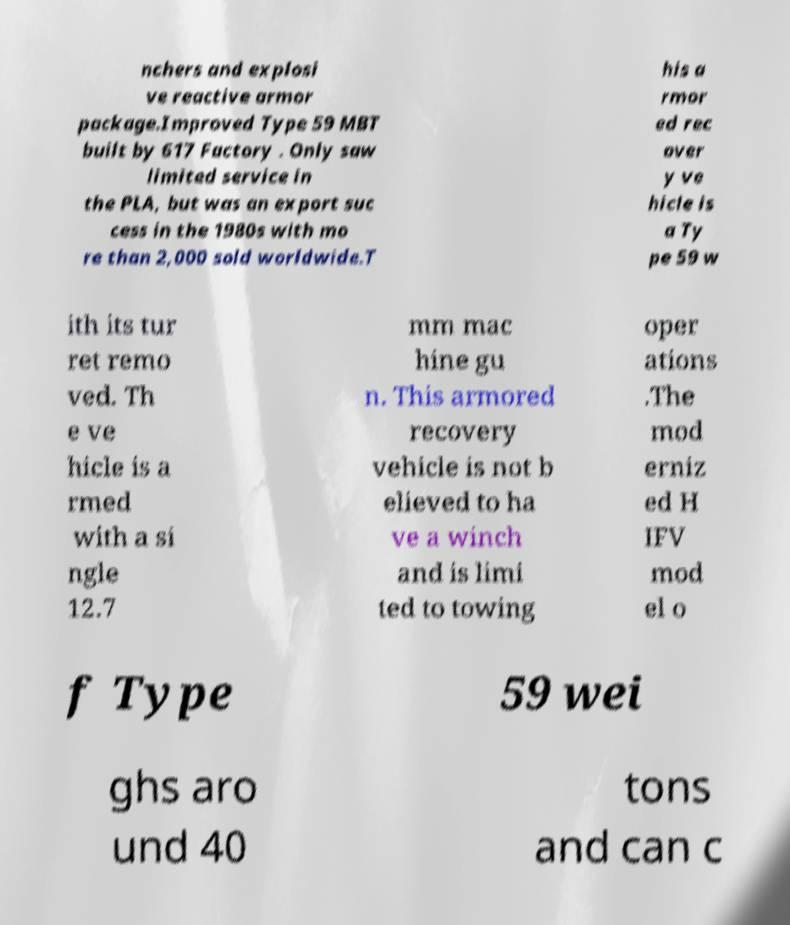Please read and relay the text visible in this image. What does it say? nchers and explosi ve reactive armor package.Improved Type 59 MBT built by 617 Factory . Only saw limited service in the PLA, but was an export suc cess in the 1980s with mo re than 2,000 sold worldwide.T his a rmor ed rec over y ve hicle is a Ty pe 59 w ith its tur ret remo ved. Th e ve hicle is a rmed with a si ngle 12.7 mm mac hine gu n. This armored recovery vehicle is not b elieved to ha ve a winch and is limi ted to towing oper ations .The mod erniz ed H IFV mod el o f Type 59 wei ghs aro und 40 tons and can c 